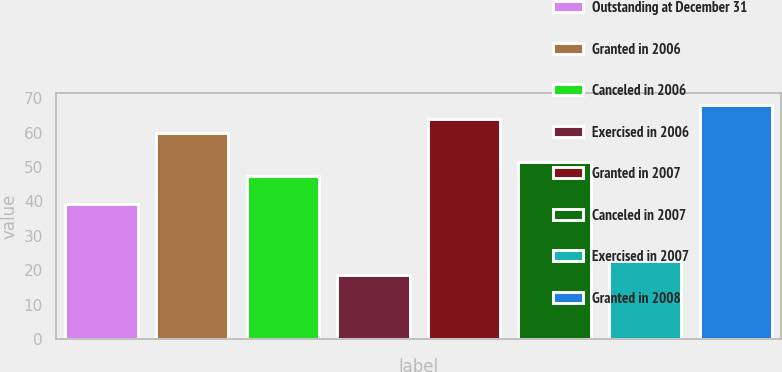<chart> <loc_0><loc_0><loc_500><loc_500><bar_chart><fcel>Outstanding at December 31<fcel>Granted in 2006<fcel>Canceled in 2006<fcel>Exercised in 2006<fcel>Granted in 2007<fcel>Canceled in 2007<fcel>Exercised in 2007<fcel>Granted in 2008<nl><fcel>39.21<fcel>59.81<fcel>47.45<fcel>18.61<fcel>63.93<fcel>51.57<fcel>22.73<fcel>68.05<nl></chart> 